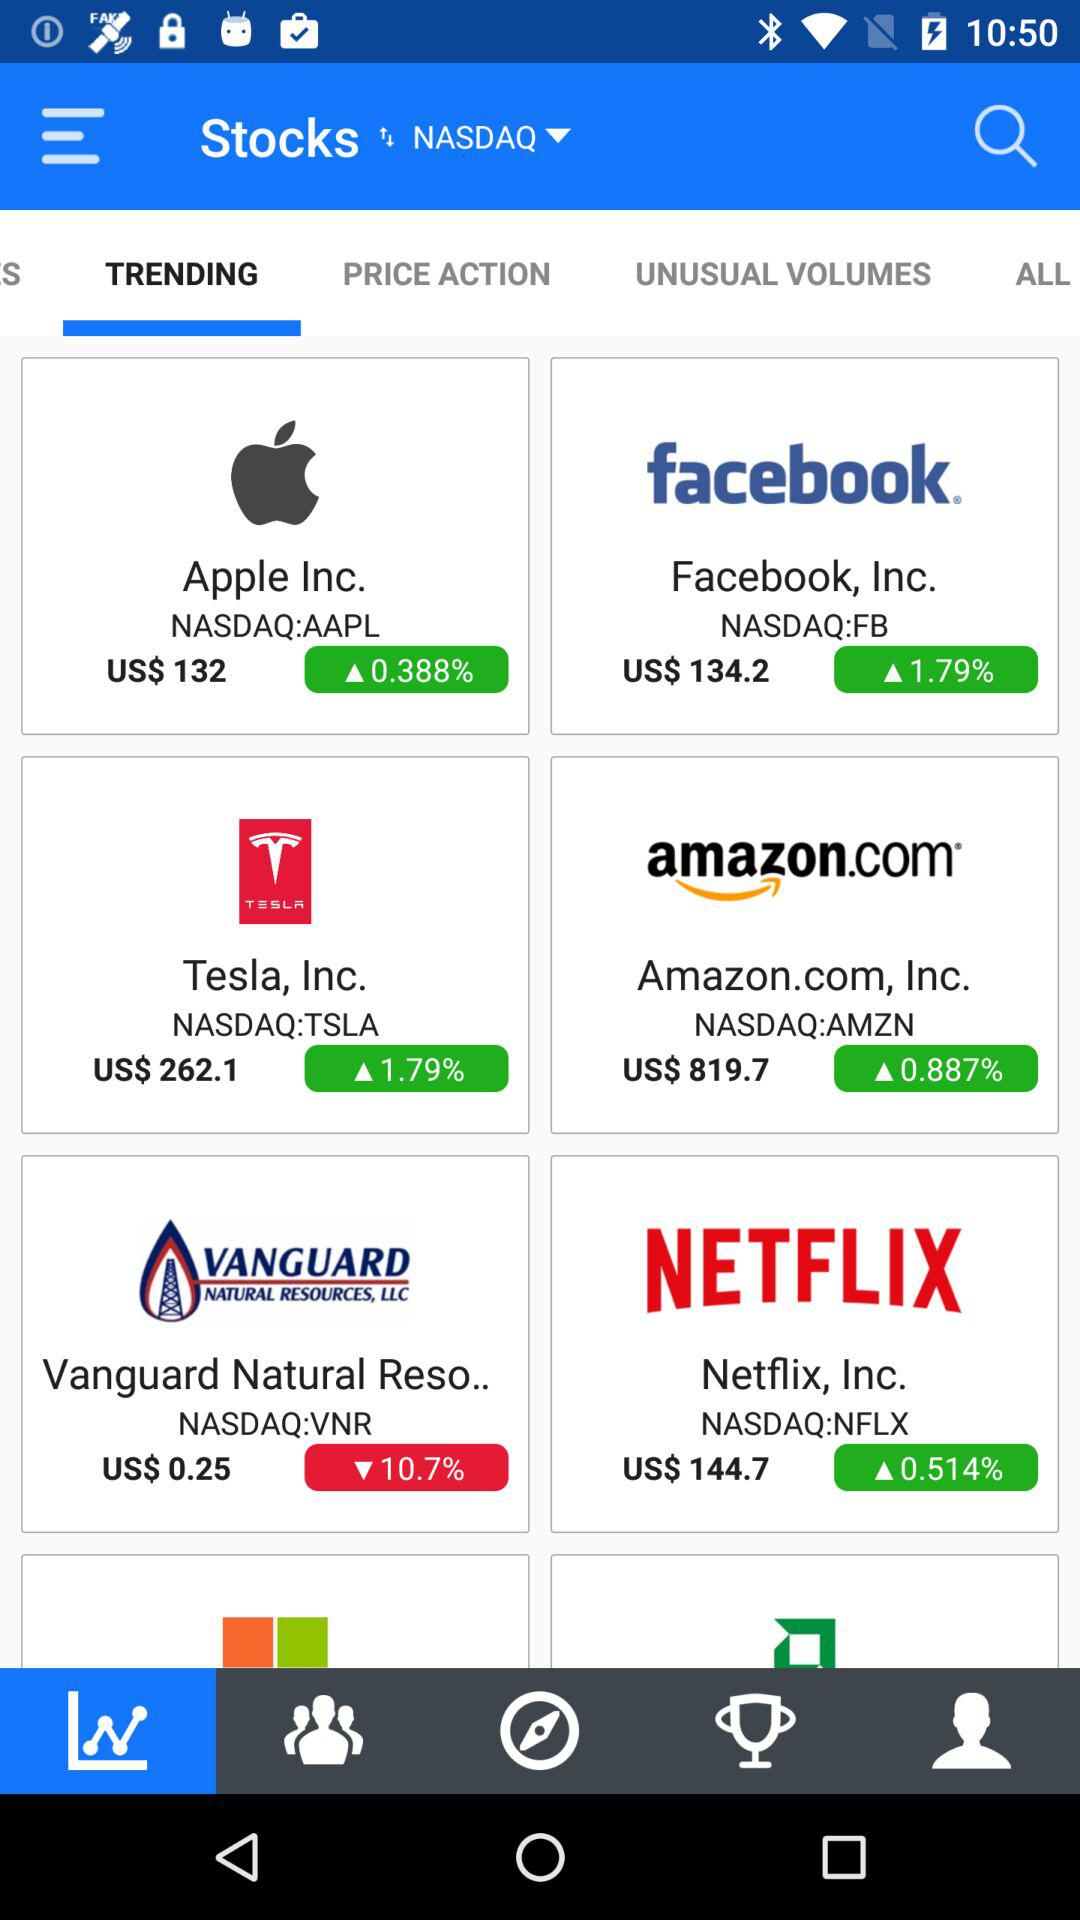Which tab is selected? The selected tabs are "TRENDING" and "Charts". 